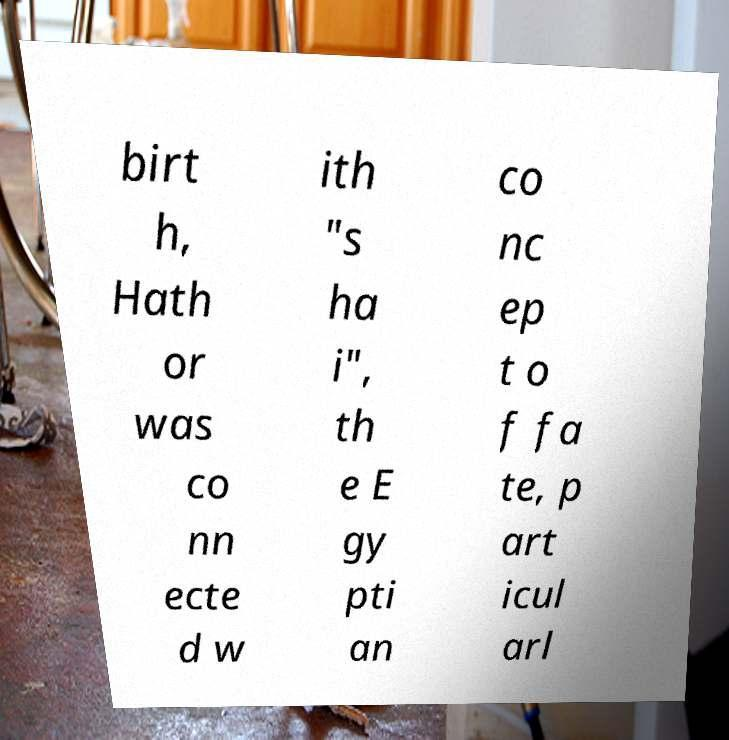Please read and relay the text visible in this image. What does it say? birt h, Hath or was co nn ecte d w ith "s ha i", th e E gy pti an co nc ep t o f fa te, p art icul arl 